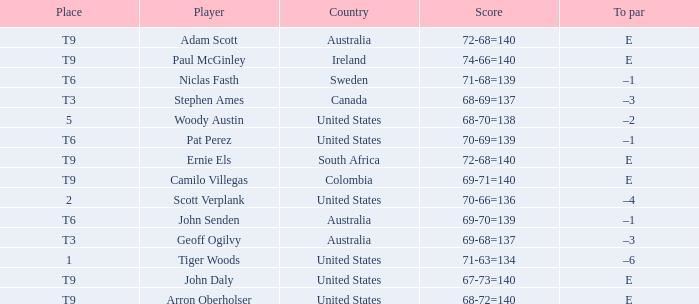Which country has a score of 70-66=136? United States. Could you help me parse every detail presented in this table? {'header': ['Place', 'Player', 'Country', 'Score', 'To par'], 'rows': [['T9', 'Adam Scott', 'Australia', '72-68=140', 'E'], ['T9', 'Paul McGinley', 'Ireland', '74-66=140', 'E'], ['T6', 'Niclas Fasth', 'Sweden', '71-68=139', '–1'], ['T3', 'Stephen Ames', 'Canada', '68-69=137', '–3'], ['5', 'Woody Austin', 'United States', '68-70=138', '–2'], ['T6', 'Pat Perez', 'United States', '70-69=139', '–1'], ['T9', 'Ernie Els', 'South Africa', '72-68=140', 'E'], ['T9', 'Camilo Villegas', 'Colombia', '69-71=140', 'E'], ['2', 'Scott Verplank', 'United States', '70-66=136', '–4'], ['T6', 'John Senden', 'Australia', '69-70=139', '–1'], ['T3', 'Geoff Ogilvy', 'Australia', '69-68=137', '–3'], ['1', 'Tiger Woods', 'United States', '71-63=134', '–6'], ['T9', 'John Daly', 'United States', '67-73=140', 'E'], ['T9', 'Arron Oberholser', 'United States', '68-72=140', 'E']]} 